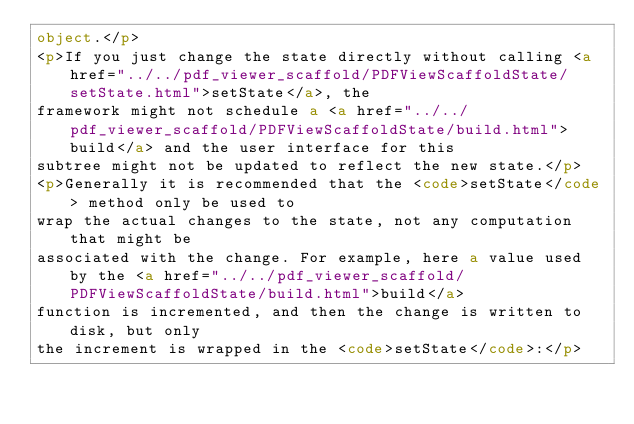Convert code to text. <code><loc_0><loc_0><loc_500><loc_500><_HTML_>object.</p>
<p>If you just change the state directly without calling <a href="../../pdf_viewer_scaffold/PDFViewScaffoldState/setState.html">setState</a>, the
framework might not schedule a <a href="../../pdf_viewer_scaffold/PDFViewScaffoldState/build.html">build</a> and the user interface for this
subtree might not be updated to reflect the new state.</p>
<p>Generally it is recommended that the <code>setState</code> method only be used to
wrap the actual changes to the state, not any computation that might be
associated with the change. For example, here a value used by the <a href="../../pdf_viewer_scaffold/PDFViewScaffoldState/build.html">build</a>
function is incremented, and then the change is written to disk, but only
the increment is wrapped in the <code>setState</code>:</p></code> 